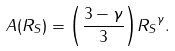<formula> <loc_0><loc_0><loc_500><loc_500>A ( R _ { S } ) = { \left ( \frac { 3 - \gamma } { 3 } \right ) } { R _ { S } } ^ { \gamma } .</formula> 